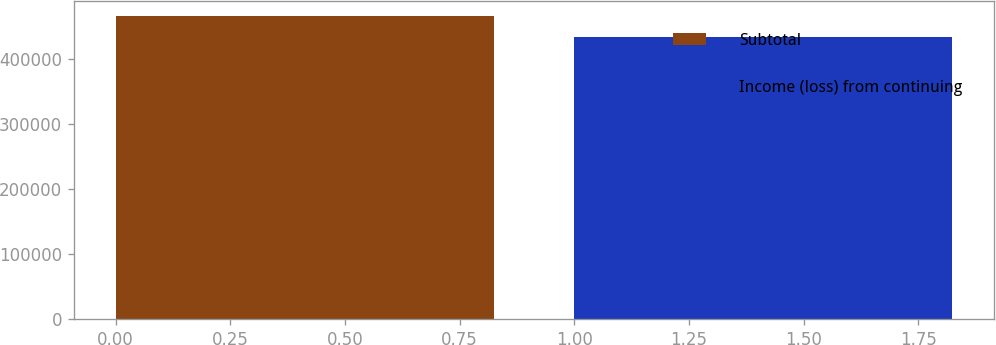Convert chart. <chart><loc_0><loc_0><loc_500><loc_500><bar_chart><fcel>Subtotal<fcel>Income (loss) from continuing<nl><fcel>465231<fcel>432842<nl></chart> 